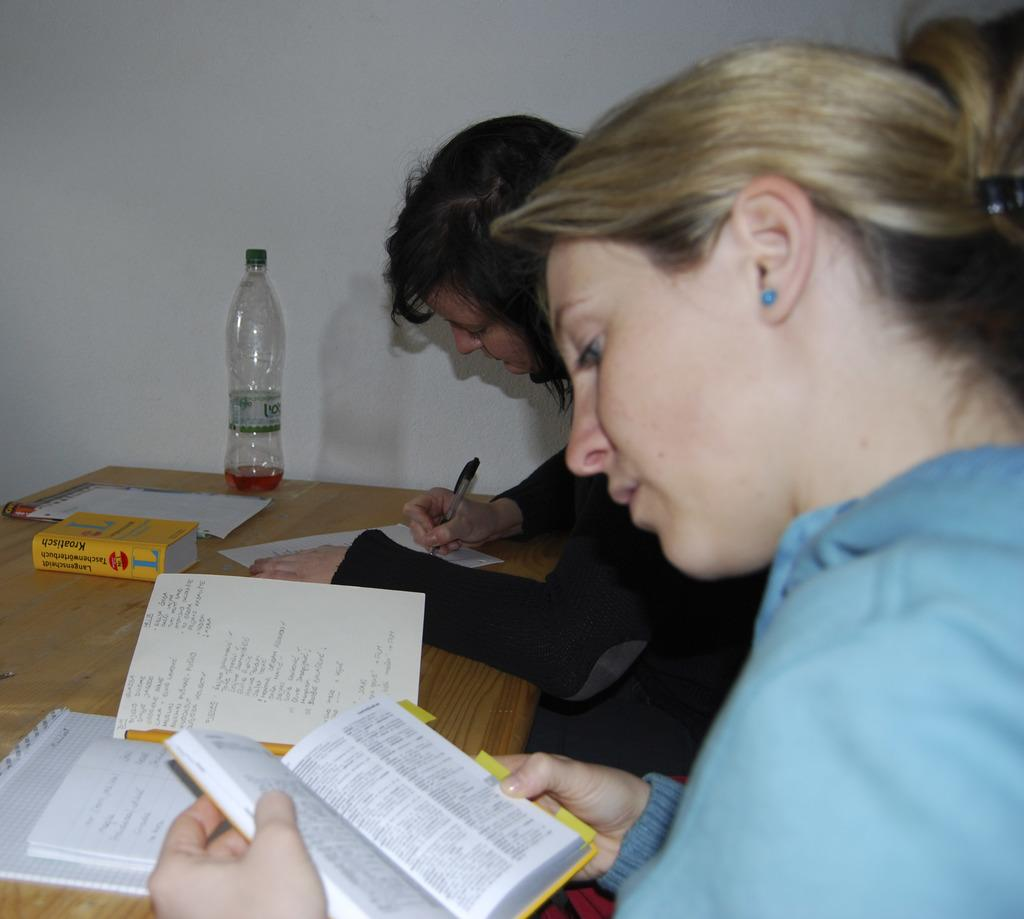<image>
Present a compact description of the photo's key features. A yellow book which says, "Kroatisch" sits on a desk where two girls are studying. 